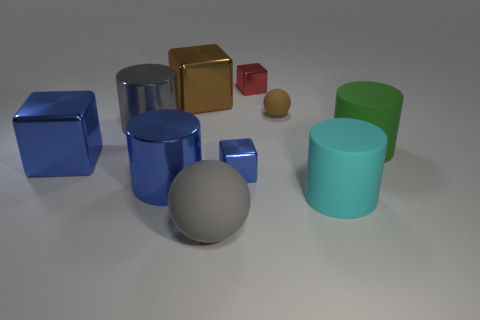Subtract all cubes. How many objects are left? 6 Add 3 large blue metal blocks. How many large blue metal blocks exist? 4 Subtract 1 cyan cylinders. How many objects are left? 9 Subtract all large shiny cylinders. Subtract all large metallic cubes. How many objects are left? 6 Add 7 large brown cubes. How many large brown cubes are left? 8 